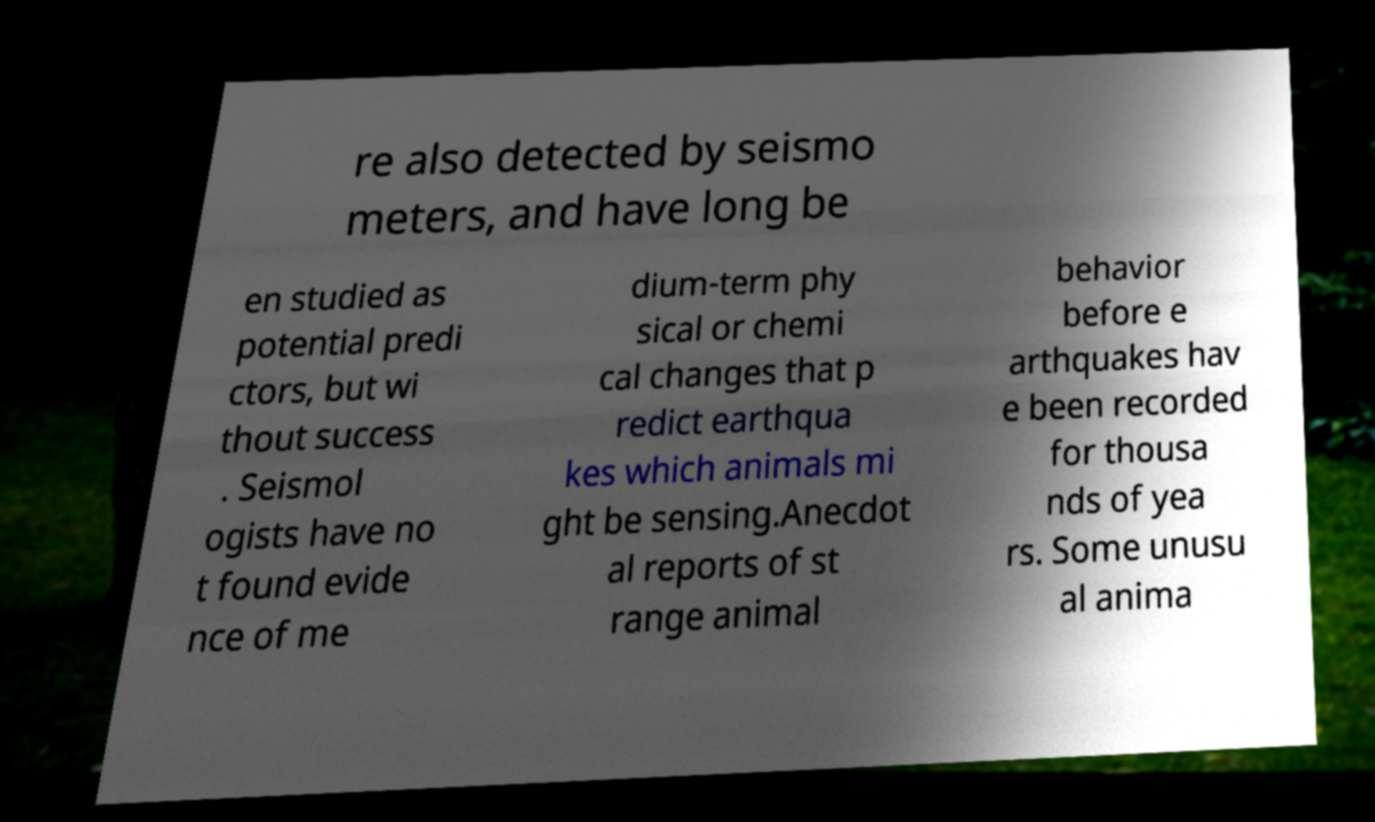For documentation purposes, I need the text within this image transcribed. Could you provide that? re also detected by seismo meters, and have long be en studied as potential predi ctors, but wi thout success . Seismol ogists have no t found evide nce of me dium-term phy sical or chemi cal changes that p redict earthqua kes which animals mi ght be sensing.Anecdot al reports of st range animal behavior before e arthquakes hav e been recorded for thousa nds of yea rs. Some unusu al anima 